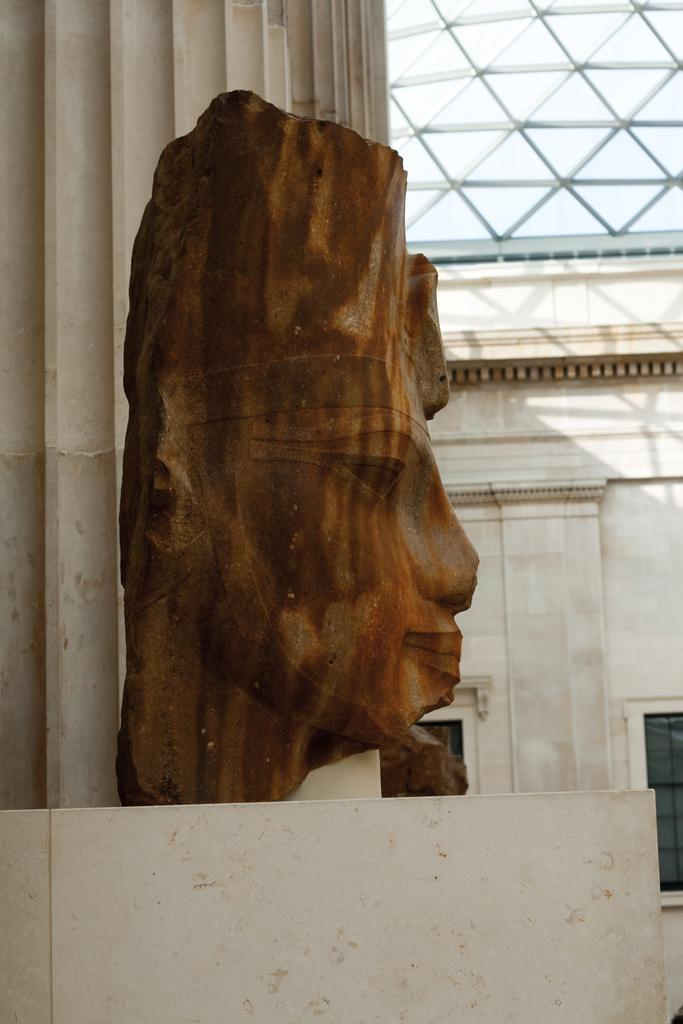What is the main subject of the image? There is a wooden sculpture of a woman's face in the image. What is the sculpture placed on? The sculpture is placed on a marble top. What can be seen in the background of the image? There is a glass shed in the background of the image. How many ants are crawling on the wooden sculpture in the image? There are no ants visible on the wooden sculpture in the image. What type of bun is being held by the woman's face in the sculpture? The wooden sculpture is of a woman's face, not a person holding a bun. 